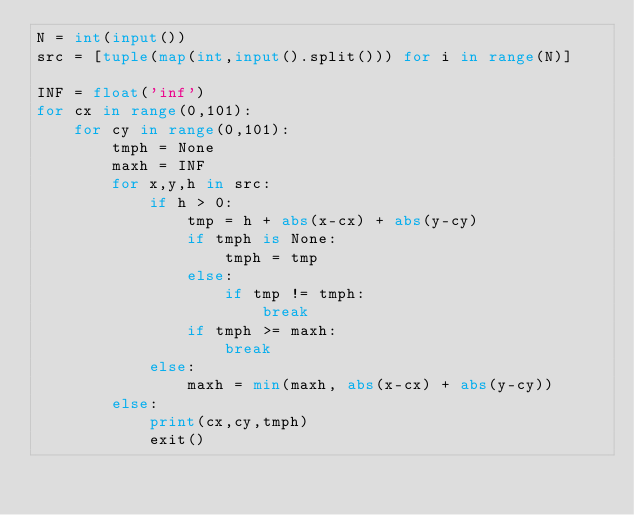<code> <loc_0><loc_0><loc_500><loc_500><_Python_>N = int(input())
src = [tuple(map(int,input().split())) for i in range(N)]

INF = float('inf')
for cx in range(0,101):
    for cy in range(0,101):
        tmph = None
        maxh = INF
        for x,y,h in src:
            if h > 0:
                tmp = h + abs(x-cx) + abs(y-cy)
                if tmph is None:
                    tmph = tmp
                else:
                    if tmp != tmph:
                        break
                if tmph >= maxh:
                    break
            else:
                maxh = min(maxh, abs(x-cx) + abs(y-cy))
        else:
            print(cx,cy,tmph)
            exit()</code> 